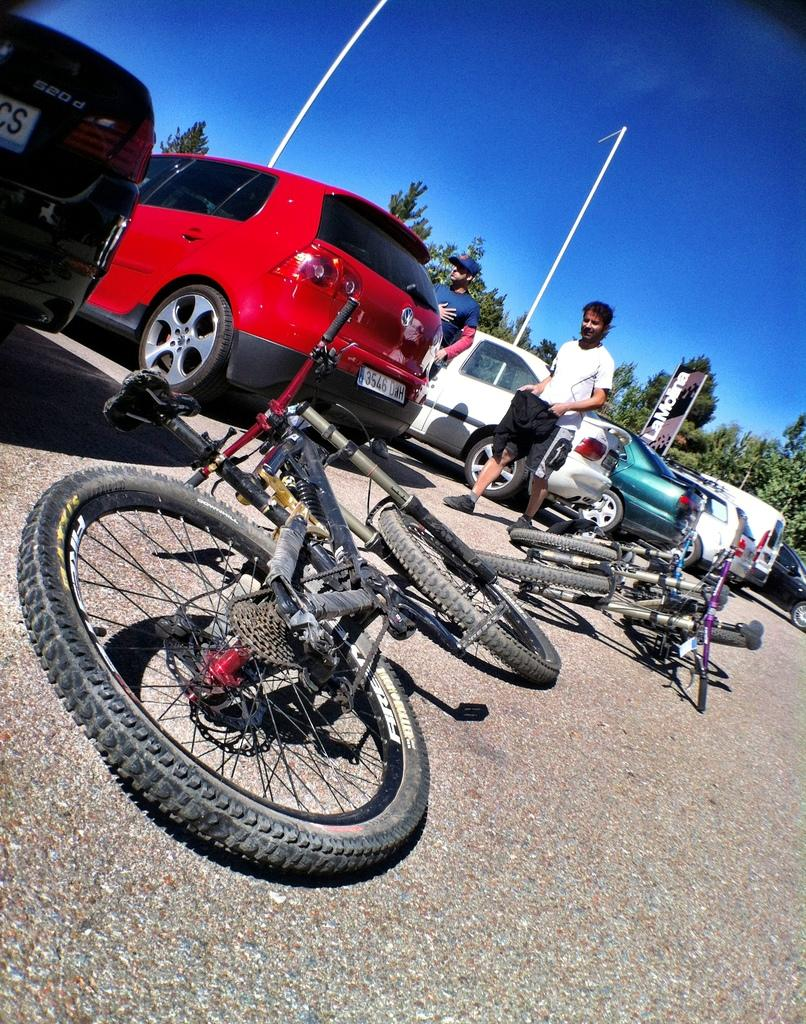What is located at the bottom of the image? There is a road at the bottom of the image. What can be seen in the middle of the image? There are vehicles in the middle of the image. What type of vegetation is in the background of the image? There are groups of trees in the background of the image. What is visible at the top of the image? The sky is visible at the top of the image. What type of frame surrounds the image? There is no frame surrounding the image; it is a photograph or digital image without a physical frame. Can you see a squirrel climbing one of the trees in the background? There is no squirrel present in the image; only vehicles, trees, and the sky are visible. 